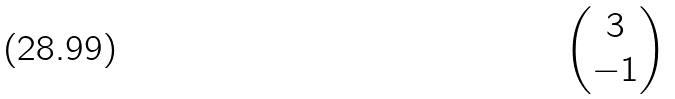<formula> <loc_0><loc_0><loc_500><loc_500>\begin{pmatrix} 3 \\ - 1 \end{pmatrix}</formula> 